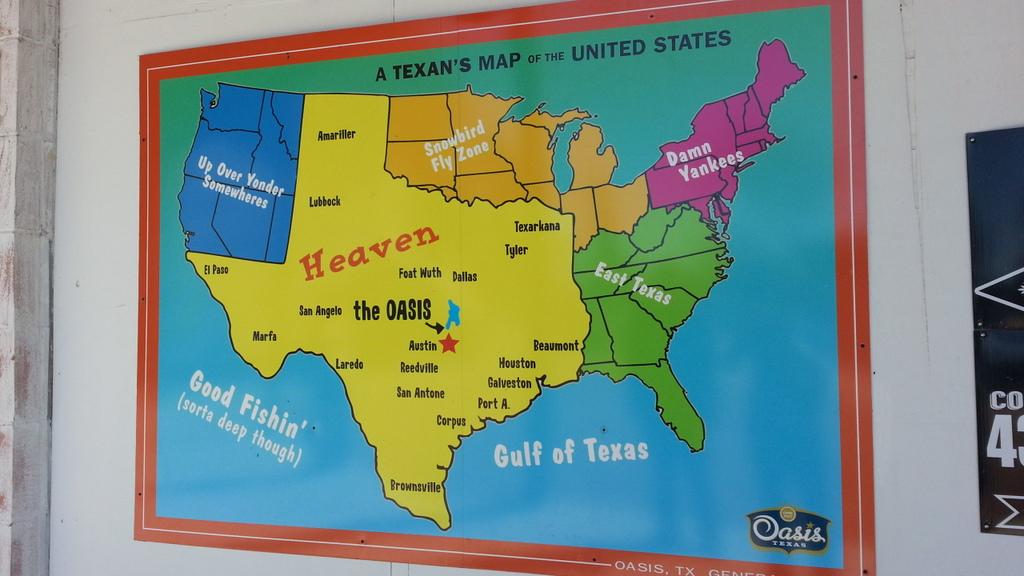What state is this a map of?
Offer a terse response. Texas. Is oasis a company or city in texas?
Your answer should be very brief. Yes. 